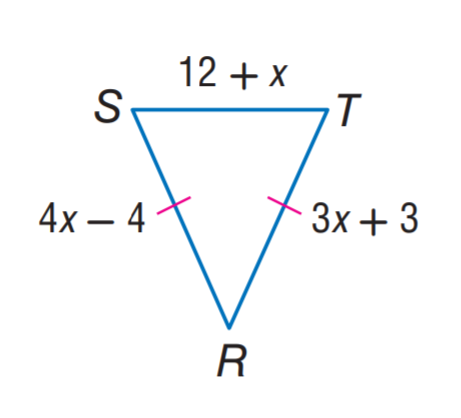Answer the mathemtical geometry problem and directly provide the correct option letter.
Question: Find S R.
Choices: A: 12 B: 24 C: 27 D: 28 B 